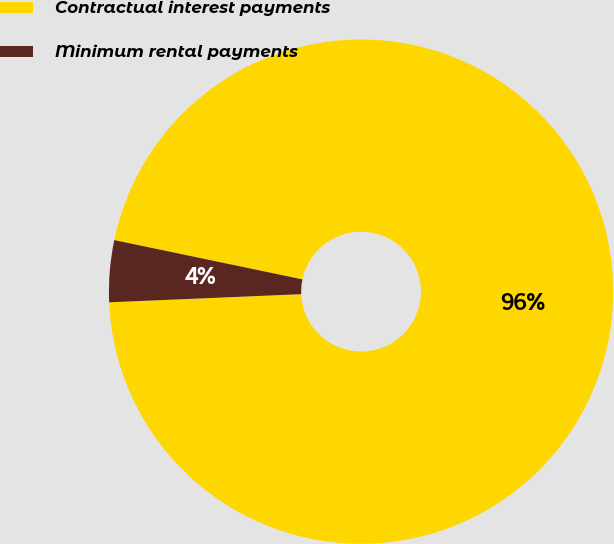Convert chart to OTSL. <chart><loc_0><loc_0><loc_500><loc_500><pie_chart><fcel>Contractual interest payments<fcel>Minimum rental payments<nl><fcel>96.05%<fcel>3.95%<nl></chart> 